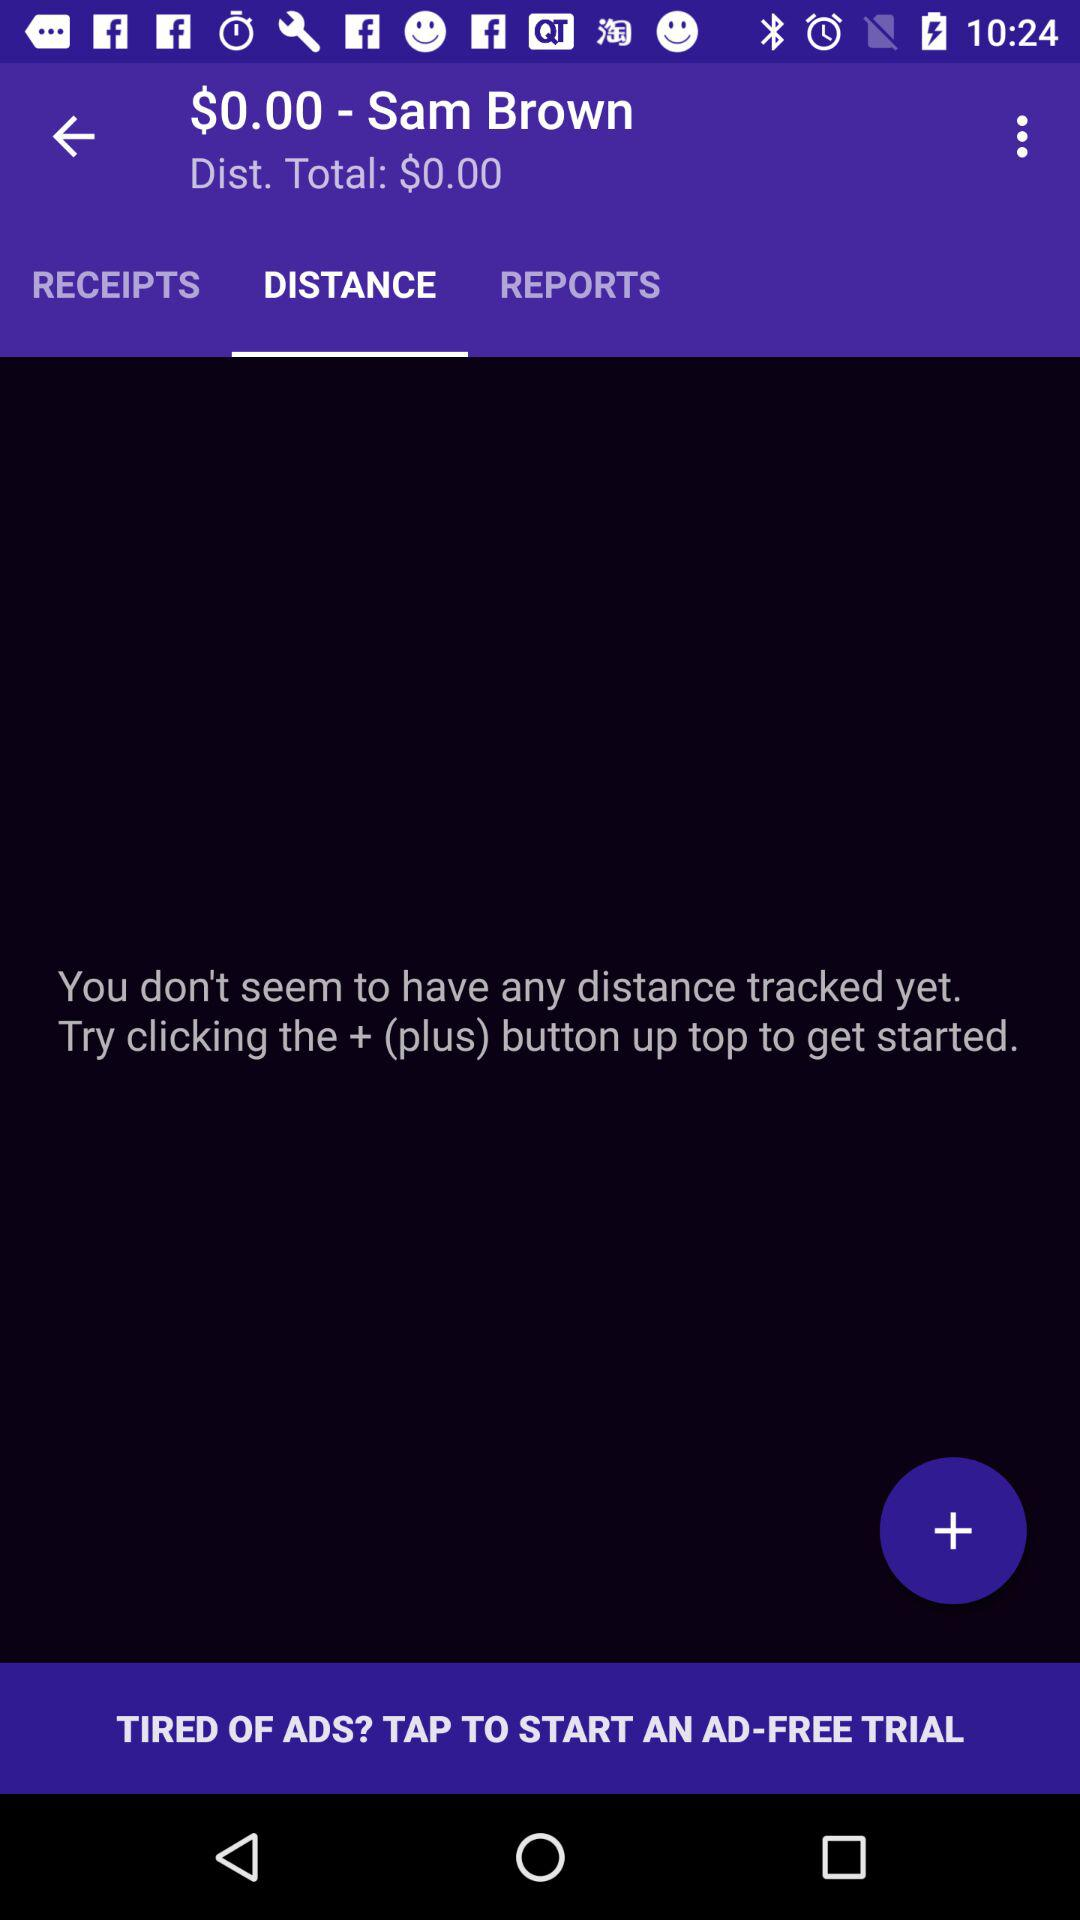How much does it cost to travel the whole distance? The cost is $0.00. 